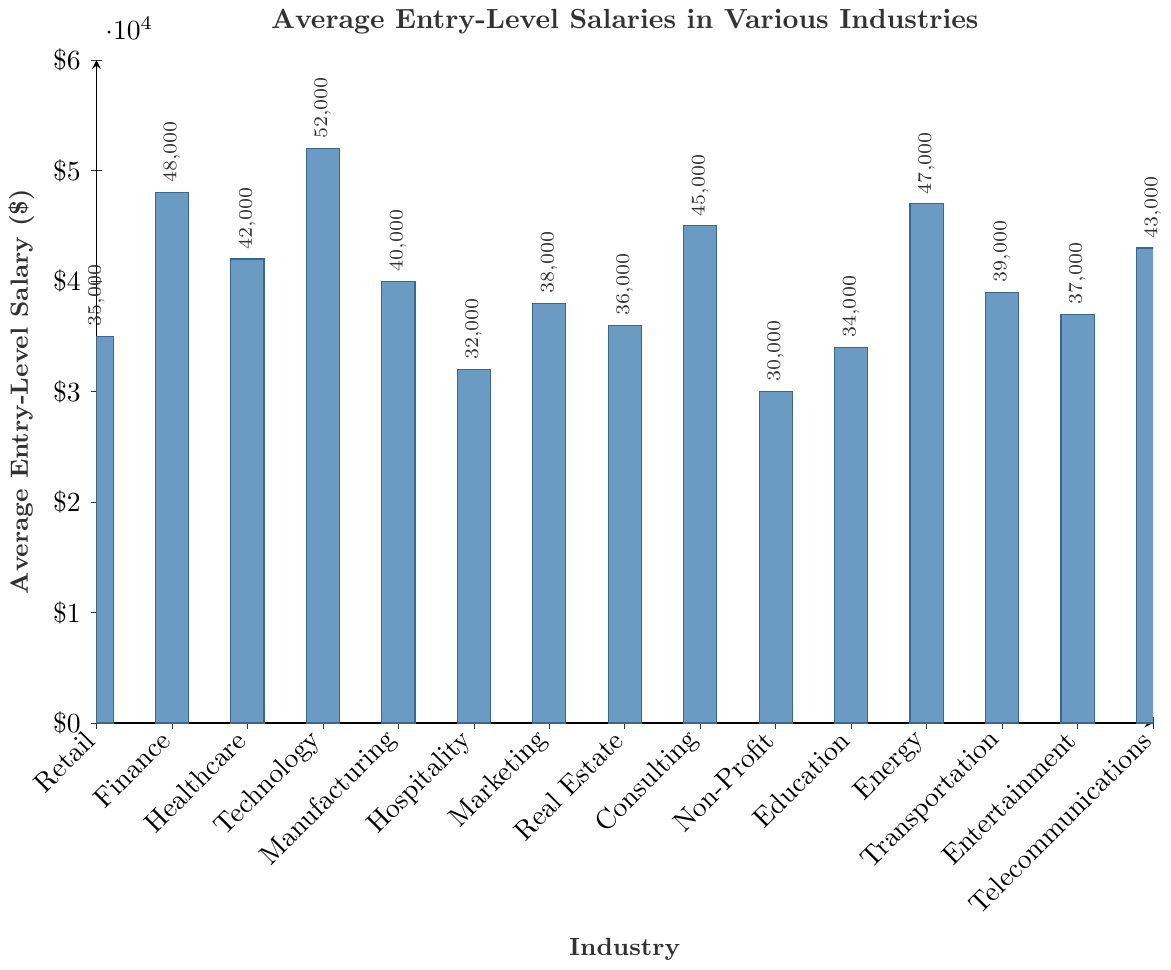Which industry has the highest average entry-level salary? To find this, look at the heights of the bars in the chart. The tallest bar indicates the highest salary.
Answer: Technology What is the difference between the average entry-level salary in Technology and Education? Identify the bars for Technology and Education. Note their heights (salaries): Technology ($52000) and Education ($34000). Subtract the smaller from the larger value.
Answer: $18000 Which two industries have the closest average entry-level salaries? Compare the heights of all bars and find the two bars that are closest in height. The smallest difference is between Entertainment ($37000) and Real Estate ($36000).
Answer: Entertainment and Real Estate What is the average entry-level salary across all industries? Sum the salaries of all industries and divide by the number of industries (15). Calculations: (35000 + 48000 + 42000 + 52000 + 40000 + 32000 + 38000 + 36000 + 45000 + 30000 + 34000 + 47000 + 39000 + 37000 + 43000) / 15 = 40266.67
Answer: $40266.67 How much more does the average entry-level salary in Finance exceed that in Non-Profit? Identify the bars for Finance and Non-Profit. Note their heights: Finance ($48000), Non-Profit ($30000). Subtract the smaller from the larger value.
Answer: $18000 Which industries have an average entry-level salary over $45000? Look for bars with heights greater than $45000. These are Technology ($52000), Finance ($48000), and Energy ($47000).
Answer: Technology, Finance, and Energy What is the median average entry-level salary among all industries? Arrange the salaries in numerical order and find the middle value. Ordered list: 30000, 32000, 34000, 35000, 36000, 37000, 38000, 39000, 40000, 42000, 43000, 45000, 47000, 48000, 52000. The median is the 8th value.
Answer: $39000 Which industry has the second highest entry-level salary? Identify the bar heights and rank them. The second tallest bar is Finance with salary $48000.
Answer: Finance How does the average entry-level salary in Healthcare compare to that in Transportation? Identify the bars for Healthcare and Transportation. Note their heights: Healthcare ($42000), Transportation ($39000). Compare the two values.
Answer: Healthcare is $3000 higher than Transportation What is the range of the average entry-level salaries across all industries? Identify the highest and lowest salaries from the bars: highest ($52000 for Technology), lowest ($30000 for Non-Profit). Subtract the lowest from the highest value.
Answer: $22000 